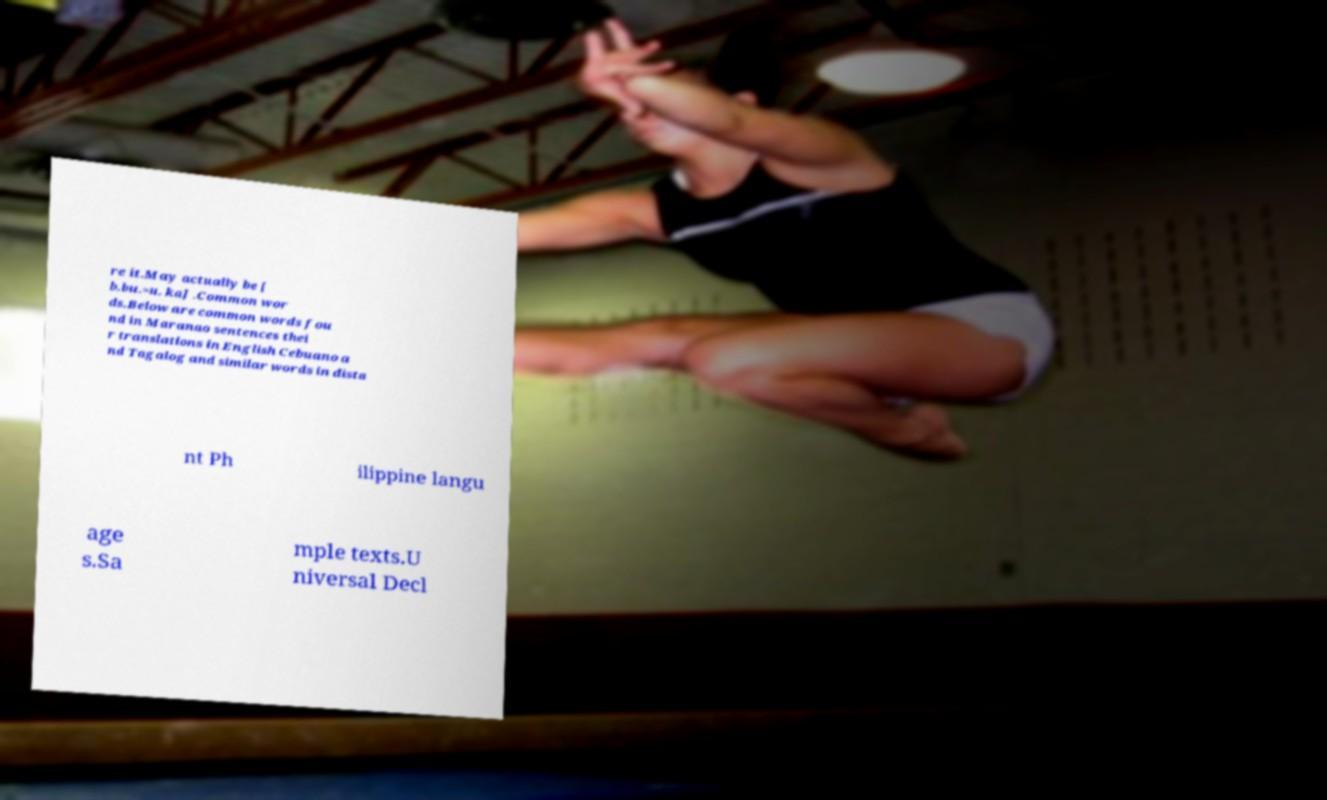There's text embedded in this image that I need extracted. Can you transcribe it verbatim? re it.May actually be [ b.bu.=u. ka] .Common wor ds.Below are common words fou nd in Maranao sentences thei r translations in English Cebuano a nd Tagalog and similar words in dista nt Ph ilippine langu age s.Sa mple texts.U niversal Decl 